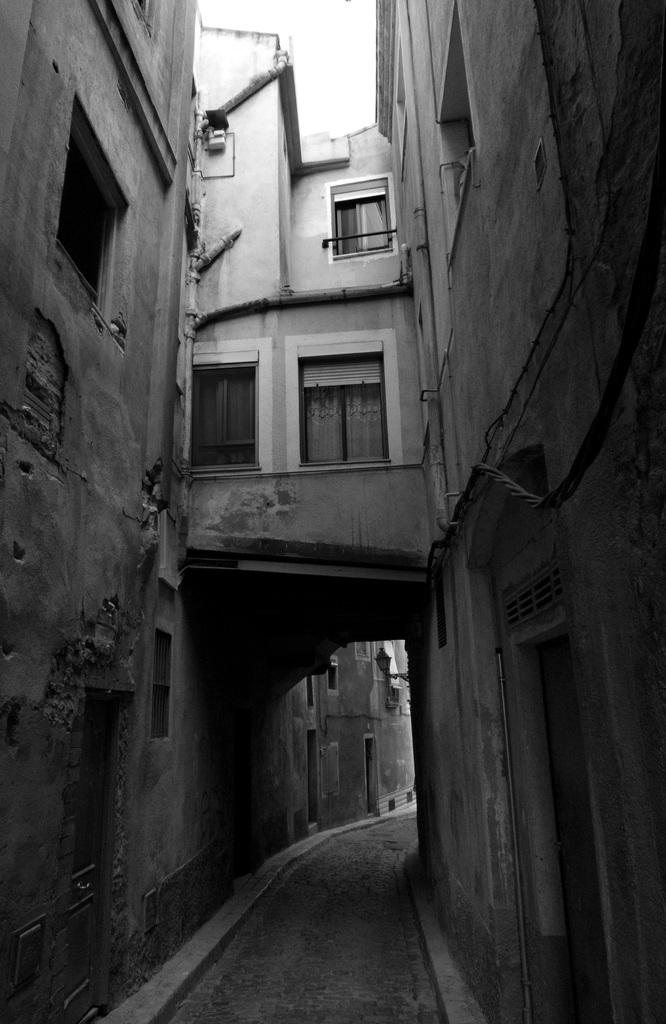What type of structures are visible in the image? There are buildings in the image. What architectural features can be seen on the buildings? There are windows and pipes on the walls visible in the image. How does the roll of paper move around in the image? There is no roll of paper present in the image. What type of lift can be seen in the image? There is no lift present in the image. 